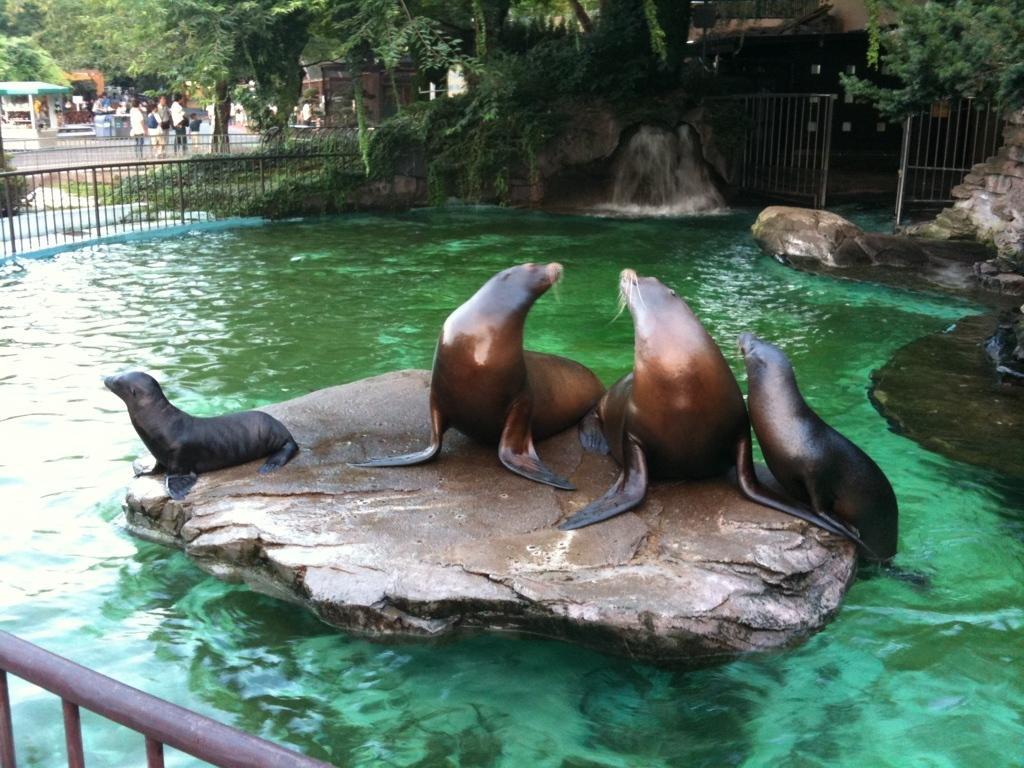In one or two sentences, can you explain what this image depicts? In this image, we can see some water. We can also see some animals. We can see some rocks in the water. There are a few trees. We can see the fence. There are a few people. We can also see a tent and some houses. We can see the ground and some plants. 